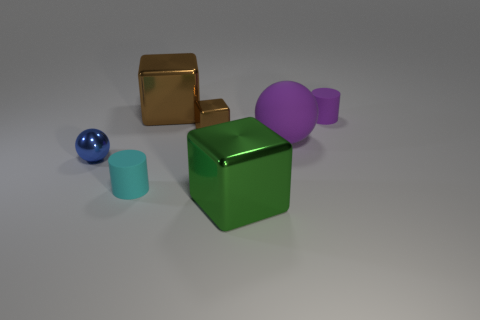Subtract all green blocks. How many blocks are left? 2 Subtract all green blocks. How many blocks are left? 2 Subtract all balls. How many objects are left? 5 Subtract 1 cylinders. How many cylinders are left? 1 Add 1 green cubes. How many objects exist? 8 Subtract 0 red balls. How many objects are left? 7 Subtract all purple cylinders. Subtract all brown cubes. How many cylinders are left? 1 Subtract all purple cylinders. How many blue spheres are left? 1 Subtract all tiny blue metallic objects. Subtract all brown metallic things. How many objects are left? 4 Add 7 small purple things. How many small purple things are left? 8 